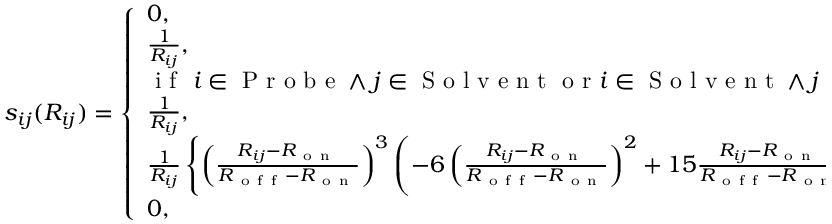Convert formula to latex. <formula><loc_0><loc_0><loc_500><loc_500>s _ { i j } ( R _ { i j } ) = \left \{ \begin{array} { l l } { 0 , } & { i f i j \in S o l v e n t } \\ { \frac { 1 } { R _ { i j } } , } & { i f i j \in P r o b e } \\ { i f i \in P r o b e \wedge j \in S o l v e n t o r i \in S o l v e n t \wedge j \in P r o b e \colon } \\ { \frac { 1 } { R _ { i j } } , } & { i f R _ { i j } \leq R _ { o n } } \\ { \frac { 1 } { R _ { i j } } \left \{ \left ( \frac { R _ { i j } - R _ { o n } } { R _ { o f f } - R _ { o n } } \right ) ^ { 3 } \left ( - 6 \left ( \frac { R _ { i j } - R _ { o n } } { R _ { o f f } - R _ { o n } } \right ) ^ { 2 } + 1 5 \frac { R _ { i j } - R _ { o n } } { R _ { o f f } - R _ { o n } } - 1 0 \right ) + 1 \right \} , } & { i f R _ { o n } < R _ { i j } < R _ { o f f } } \\ { 0 , \ } & { i f R _ { i j } \geq R _ { o f f } } \end{array}</formula> 